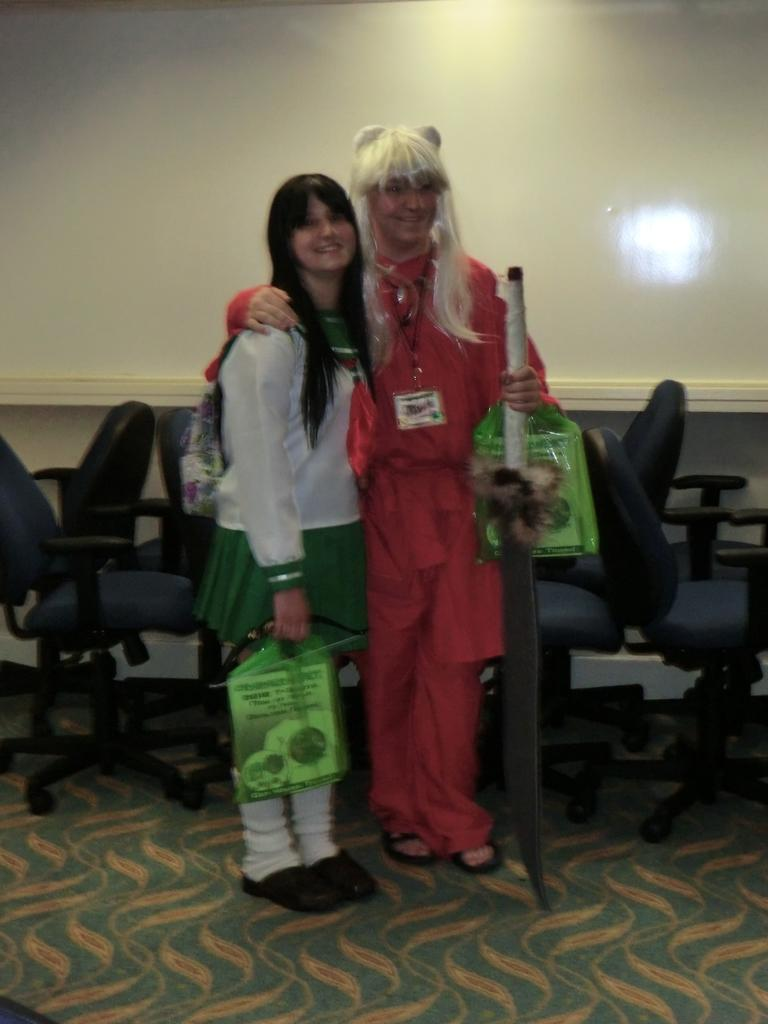How many people are in the image? There are two persons in the image. What is the facial expression of the people in the image? Both persons are smiling. Can you describe any accessories worn by one of the persons? One of the persons is wearing a bag. What can be seen in the background of the image? There are chairs and a wall visible in the background. How many cherries can be seen on the wall in the image? There are no cherries present in the image; only chairs and a wall are visible in the background. Can you tell me how many snails are crawling on the chairs in the image? There are no snails present in the image; only chairs and a wall are visible in the background. 